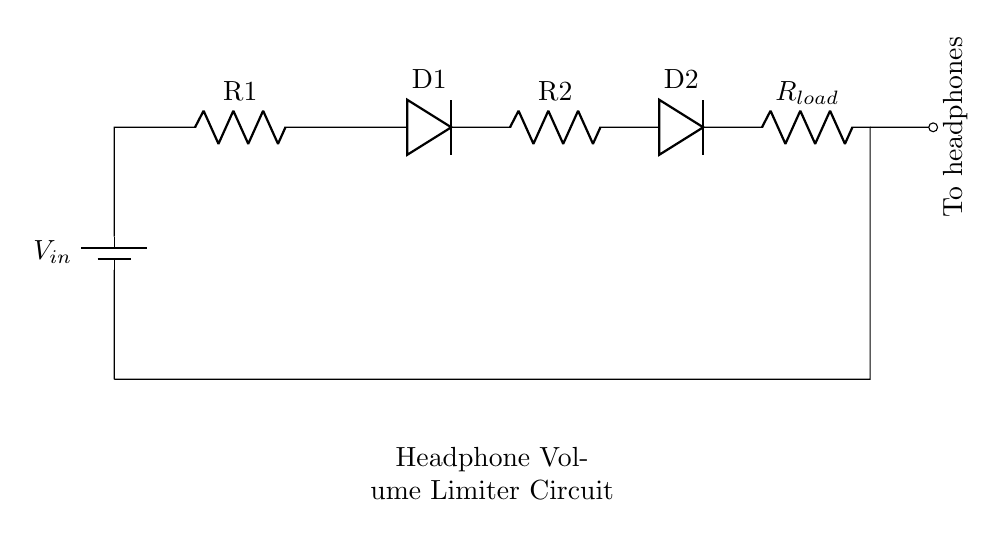What is the total number of resistors in this circuit? There are three resistors in the circuit: one labeled R1, one labeled R2, and one labeled R load. Each resistor is indicated clearly in the diagram.
Answer: three Which component limits the current in this circuit? The diodes D1 and D2 are connected in series and provide a threshold for current flow, effectively limiting the current to the headphones. Diodes conduct current only in one direction and will clamp the voltage, thus acting as current limiters in this configuration.
Answer: diodes What is the purpose of the diodes in this circuit? The diodes are used to limit the voltage that the headphones receive, preventing damage from excessive voltage. By preventing the voltage from exceeding a certain level, the diodes protect the headphones from potential sound damage.
Answer: voltage limitation If the input voltage is 12 volts, how many volts are expected across the headphones? The voltage across the headphones will depend on the forward voltage drop of the diodes and the resistors’ values, but typically the voltage drop across each diode is about 0.7 volts. Assuming both diodes are conducting, that's a total of 1.4 volts dropped, leaving approximately 10.6 volts across the headphones. However, exact values depend on the resistor values.
Answer: approximately 10.6 volts Identify the load component in this circuit. The load component in this circuit is labeled R load, which represents the total impedance that the headphones present to the circuit. This load will draw current when the circuit is powered and is a crucial part of ensuring the circuit works as intended.
Answer: R load 